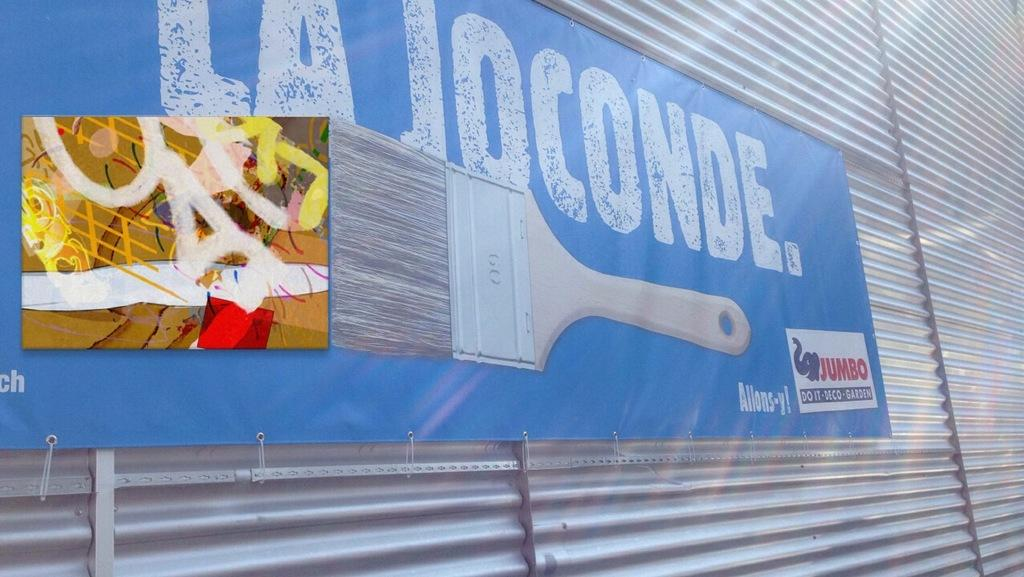<image>
Render a clear and concise summary of the photo. A blue sign that reads "la joconde" is on a corrugated wall siding. 